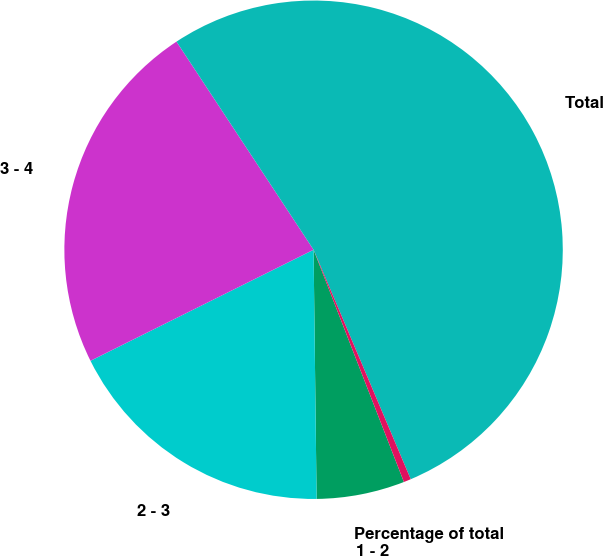Convert chart to OTSL. <chart><loc_0><loc_0><loc_500><loc_500><pie_chart><fcel>1 - 2<fcel>2 - 3<fcel>3 - 4<fcel>Total<fcel>Percentage of total<nl><fcel>5.71%<fcel>17.84%<fcel>23.08%<fcel>52.89%<fcel>0.47%<nl></chart> 